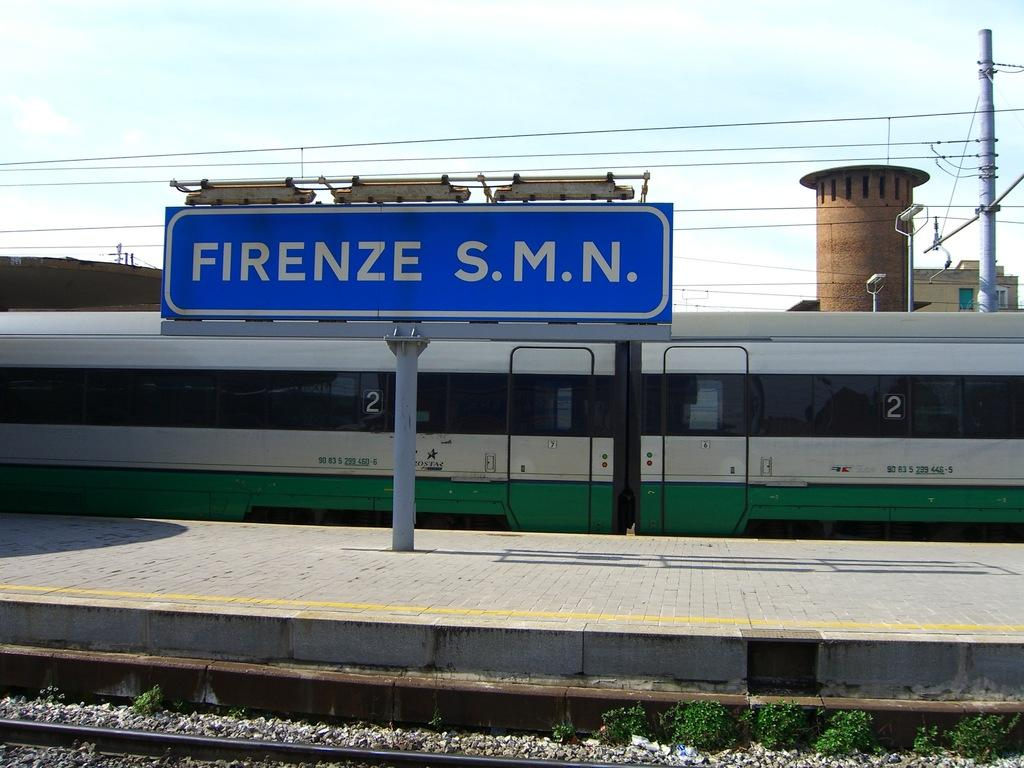Provide a one-sentence caption for the provided image. a street sign in front of a subway with the number 2 on it that reads: Firenze s.m.n. 